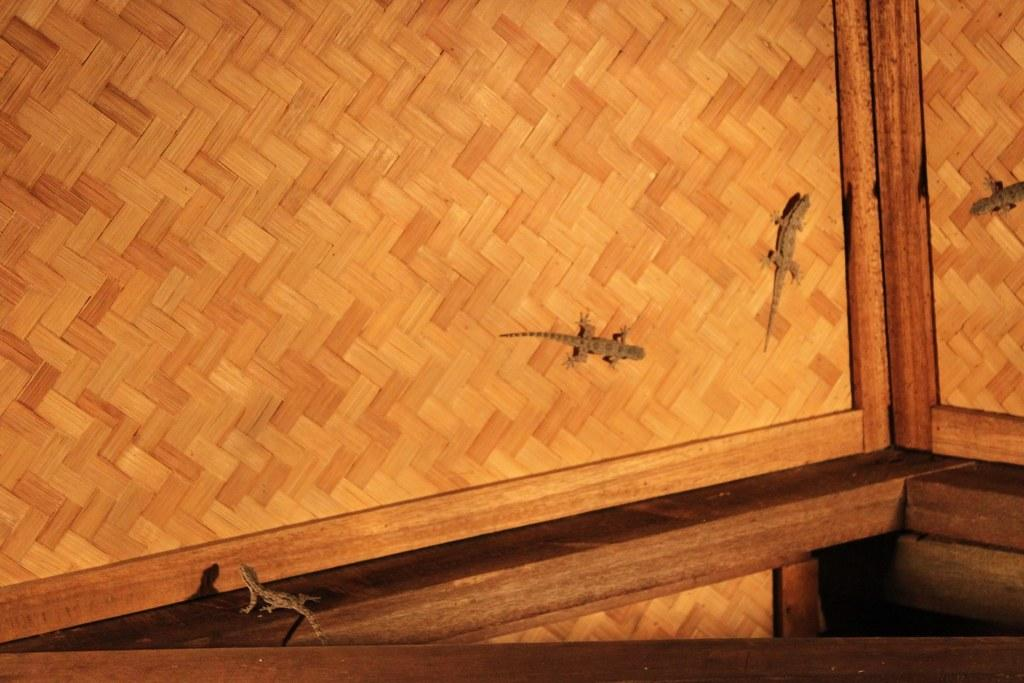How many lizards are present in the image? There are four lizards in the image. What type of surface are the lizards on? The lizards are on a wooden surface. What type of pie is being served by the fireman in the image? There is no fireman or pie present in the image; it only features four lizards on a wooden surface. 